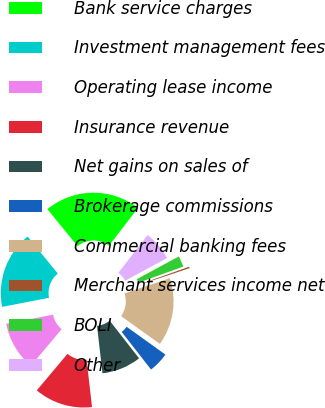Convert chart to OTSL. <chart><loc_0><loc_0><loc_500><loc_500><pie_chart><fcel>Bank service charges<fcel>Investment management fees<fcel>Operating lease income<fcel>Insurance revenue<fcel>Net gains on sales of<fcel>Brokerage commissions<fcel>Commercial banking fees<fcel>Merchant services income net<fcel>BOLI<fcel>Other<nl><fcel>21.35%<fcel>17.14%<fcel>10.84%<fcel>12.94%<fcel>8.74%<fcel>4.54%<fcel>15.04%<fcel>0.33%<fcel>2.43%<fcel>6.64%<nl></chart> 